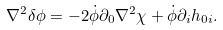Convert formula to latex. <formula><loc_0><loc_0><loc_500><loc_500>\nabla ^ { 2 } \delta \phi = - 2 \dot { \phi } \partial _ { 0 } \nabla ^ { 2 } \chi + \dot { \phi } \partial _ { i } h _ { 0 i } .</formula> 